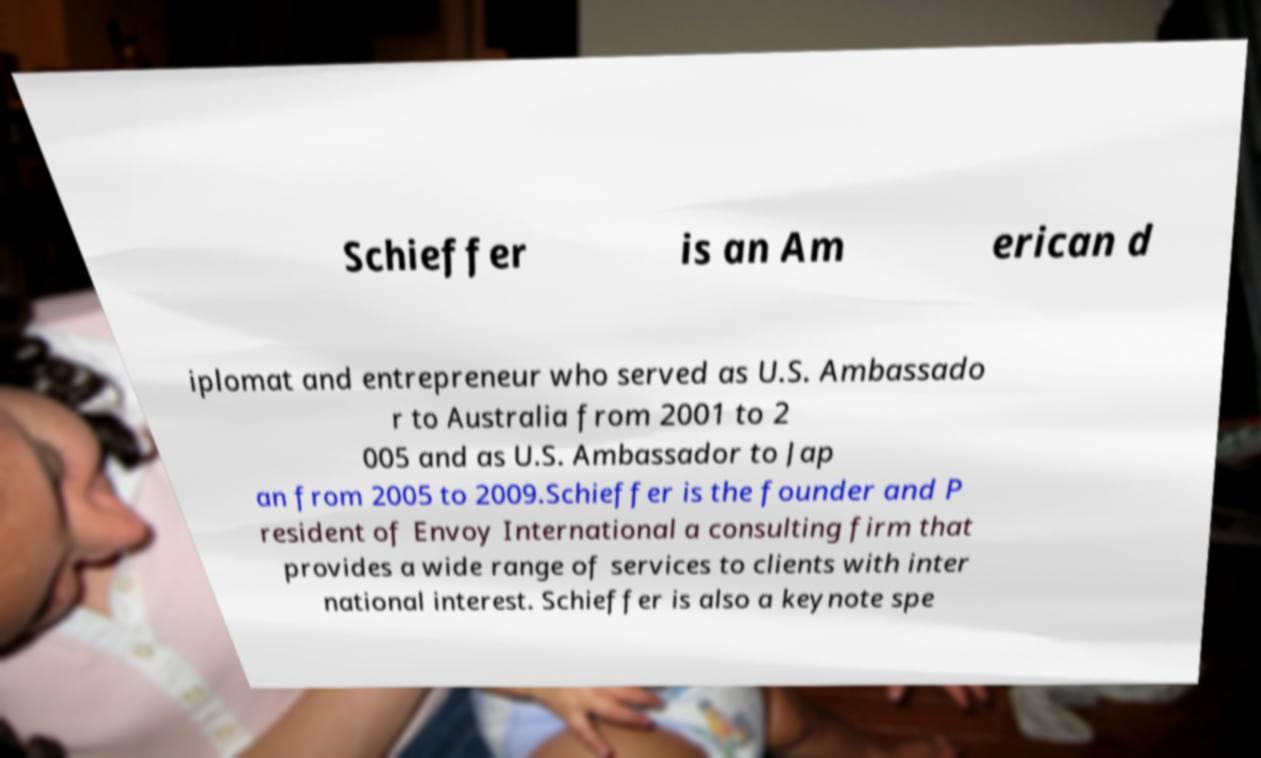Please read and relay the text visible in this image. What does it say? Schieffer is an Am erican d iplomat and entrepreneur who served as U.S. Ambassado r to Australia from 2001 to 2 005 and as U.S. Ambassador to Jap an from 2005 to 2009.Schieffer is the founder and P resident of Envoy International a consulting firm that provides a wide range of services to clients with inter national interest. Schieffer is also a keynote spe 